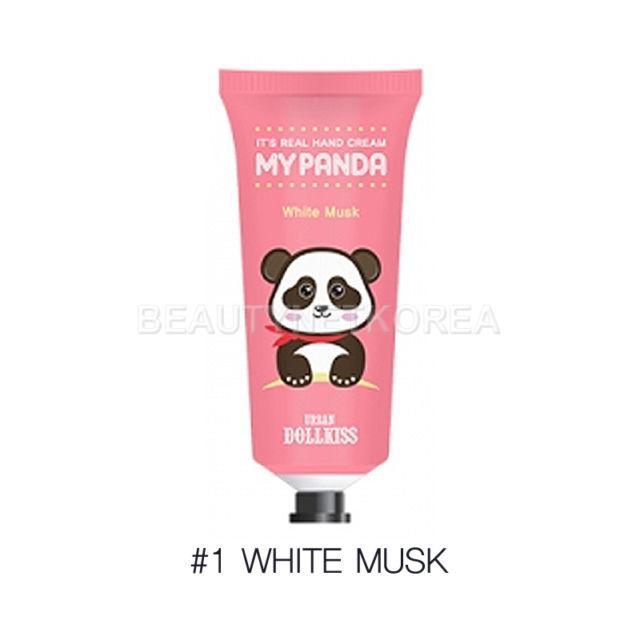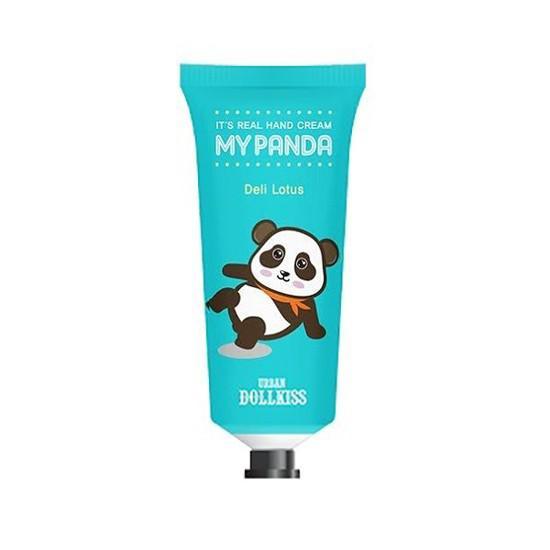The first image is the image on the left, the second image is the image on the right. Evaluate the accuracy of this statement regarding the images: "There are pink, red, and white bottles next to each other in that order, and also blue and purple in that order.". Is it true? Answer yes or no. No. The first image is the image on the left, the second image is the image on the right. Considering the images on both sides, is "Each image shows five tubes, each a different color and with assorted cartoon pandas on their fronts." valid? Answer yes or no. No. 